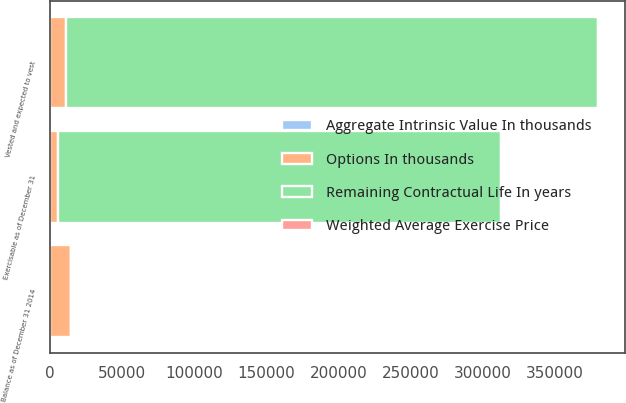Convert chart to OTSL. <chart><loc_0><loc_0><loc_500><loc_500><stacked_bar_chart><ecel><fcel>Balance as of December 31 2014<fcel>Exercisable as of December 31<fcel>Vested and expected to vest<nl><fcel>Options In thousands<fcel>14435<fcel>5636<fcel>10985<nl><fcel>Aggregate Intrinsic Value In thousands<fcel>49.33<fcel>30.92<fcel>51.9<nl><fcel>Weighted Average Exercise Price<fcel>4.1<fcel>2.4<fcel>4.9<nl><fcel>Remaining Contractual Life In years<fcel>51.9<fcel>306808<fcel>368851<nl></chart> 